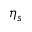Convert formula to latex. <formula><loc_0><loc_0><loc_500><loc_500>\eta _ { s }</formula> 